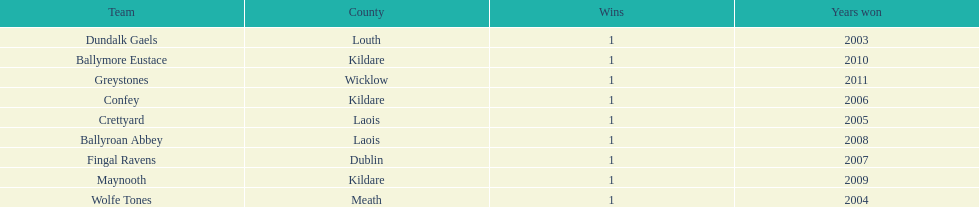Which team was the previous winner before ballyroan abbey in 2008? Fingal Ravens. 